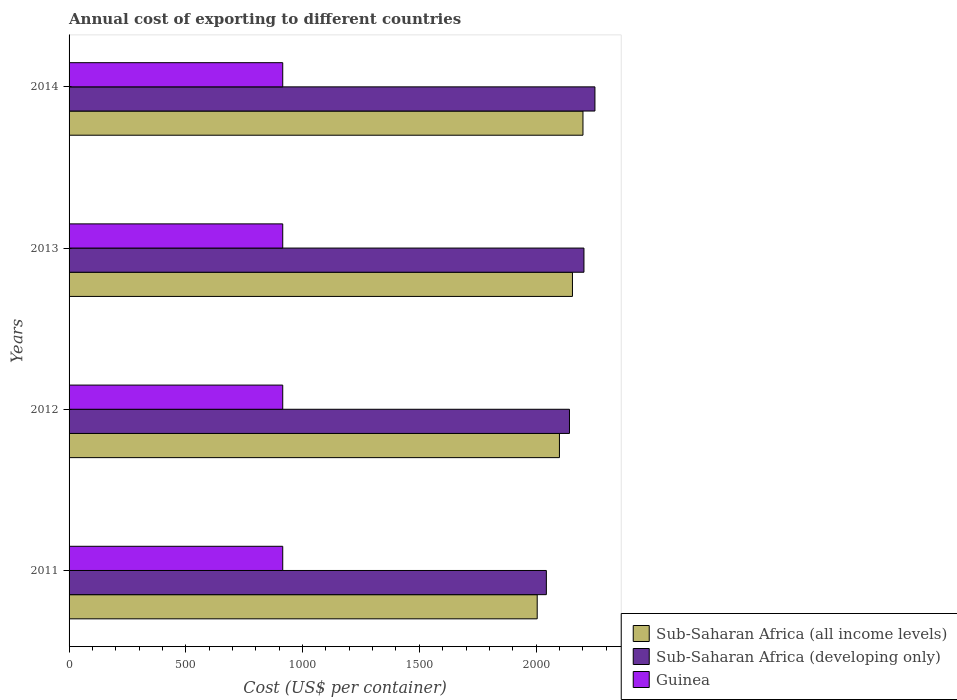In how many cases, is the number of bars for a given year not equal to the number of legend labels?
Ensure brevity in your answer.  0. What is the total annual cost of exporting in Guinea in 2014?
Offer a very short reply. 915. Across all years, what is the maximum total annual cost of exporting in Guinea?
Offer a terse response. 915. Across all years, what is the minimum total annual cost of exporting in Sub-Saharan Africa (developing only)?
Your answer should be compact. 2043.91. In which year was the total annual cost of exporting in Sub-Saharan Africa (developing only) maximum?
Provide a succinct answer. 2014. In which year was the total annual cost of exporting in Sub-Saharan Africa (developing only) minimum?
Your answer should be very brief. 2011. What is the total total annual cost of exporting in Sub-Saharan Africa (developing only) in the graph?
Your answer should be compact. 8643.75. What is the difference between the total annual cost of exporting in Sub-Saharan Africa (developing only) in 2014 and the total annual cost of exporting in Guinea in 2013?
Make the answer very short. 1336.96. What is the average total annual cost of exporting in Sub-Saharan Africa (all income levels) per year?
Give a very brief answer. 2115.28. In the year 2011, what is the difference between the total annual cost of exporting in Guinea and total annual cost of exporting in Sub-Saharan Africa (developing only)?
Ensure brevity in your answer.  -1128.91. What is the ratio of the total annual cost of exporting in Sub-Saharan Africa (all income levels) in 2011 to that in 2012?
Offer a terse response. 0.95. Is the difference between the total annual cost of exporting in Guinea in 2012 and 2014 greater than the difference between the total annual cost of exporting in Sub-Saharan Africa (developing only) in 2012 and 2014?
Give a very brief answer. Yes. What is the difference between the highest and the second highest total annual cost of exporting in Sub-Saharan Africa (developing only)?
Your answer should be compact. 47. What is the difference between the highest and the lowest total annual cost of exporting in Sub-Saharan Africa (all income levels)?
Offer a very short reply. 195.94. In how many years, is the total annual cost of exporting in Sub-Saharan Africa (all income levels) greater than the average total annual cost of exporting in Sub-Saharan Africa (all income levels) taken over all years?
Your response must be concise. 2. What does the 2nd bar from the top in 2011 represents?
Make the answer very short. Sub-Saharan Africa (developing only). What does the 2nd bar from the bottom in 2011 represents?
Your answer should be very brief. Sub-Saharan Africa (developing only). Is it the case that in every year, the sum of the total annual cost of exporting in Sub-Saharan Africa (developing only) and total annual cost of exporting in Sub-Saharan Africa (all income levels) is greater than the total annual cost of exporting in Guinea?
Your answer should be very brief. Yes. How many bars are there?
Give a very brief answer. 12. What is the difference between two consecutive major ticks on the X-axis?
Offer a very short reply. 500. Are the values on the major ticks of X-axis written in scientific E-notation?
Offer a very short reply. No. How many legend labels are there?
Offer a very short reply. 3. How are the legend labels stacked?
Your answer should be compact. Vertical. What is the title of the graph?
Provide a short and direct response. Annual cost of exporting to different countries. Does "Small states" appear as one of the legend labels in the graph?
Your answer should be compact. No. What is the label or title of the X-axis?
Keep it short and to the point. Cost (US$ per container). What is the label or title of the Y-axis?
Offer a terse response. Years. What is the Cost (US$ per container) of Sub-Saharan Africa (all income levels) in 2011?
Give a very brief answer. 2004.76. What is the Cost (US$ per container) of Sub-Saharan Africa (developing only) in 2011?
Your answer should be compact. 2043.91. What is the Cost (US$ per container) of Guinea in 2011?
Provide a succinct answer. 915. What is the Cost (US$ per container) in Sub-Saharan Africa (all income levels) in 2012?
Give a very brief answer. 2099.96. What is the Cost (US$ per container) in Sub-Saharan Africa (developing only) in 2012?
Your answer should be compact. 2142.93. What is the Cost (US$ per container) in Guinea in 2012?
Offer a terse response. 915. What is the Cost (US$ per container) in Sub-Saharan Africa (all income levels) in 2013?
Provide a short and direct response. 2155.7. What is the Cost (US$ per container) of Sub-Saharan Africa (developing only) in 2013?
Your answer should be very brief. 2204.96. What is the Cost (US$ per container) of Guinea in 2013?
Your answer should be very brief. 915. What is the Cost (US$ per container) in Sub-Saharan Africa (all income levels) in 2014?
Provide a succinct answer. 2200.7. What is the Cost (US$ per container) of Sub-Saharan Africa (developing only) in 2014?
Your response must be concise. 2251.96. What is the Cost (US$ per container) of Guinea in 2014?
Your response must be concise. 915. Across all years, what is the maximum Cost (US$ per container) in Sub-Saharan Africa (all income levels)?
Your answer should be very brief. 2200.7. Across all years, what is the maximum Cost (US$ per container) in Sub-Saharan Africa (developing only)?
Make the answer very short. 2251.96. Across all years, what is the maximum Cost (US$ per container) of Guinea?
Your answer should be compact. 915. Across all years, what is the minimum Cost (US$ per container) of Sub-Saharan Africa (all income levels)?
Your answer should be very brief. 2004.76. Across all years, what is the minimum Cost (US$ per container) of Sub-Saharan Africa (developing only)?
Your answer should be compact. 2043.91. Across all years, what is the minimum Cost (US$ per container) of Guinea?
Offer a terse response. 915. What is the total Cost (US$ per container) in Sub-Saharan Africa (all income levels) in the graph?
Your answer should be compact. 8461.12. What is the total Cost (US$ per container) of Sub-Saharan Africa (developing only) in the graph?
Offer a terse response. 8643.75. What is the total Cost (US$ per container) of Guinea in the graph?
Ensure brevity in your answer.  3660. What is the difference between the Cost (US$ per container) in Sub-Saharan Africa (all income levels) in 2011 and that in 2012?
Your response must be concise. -95.2. What is the difference between the Cost (US$ per container) in Sub-Saharan Africa (developing only) in 2011 and that in 2012?
Your response must be concise. -99.02. What is the difference between the Cost (US$ per container) in Guinea in 2011 and that in 2012?
Make the answer very short. 0. What is the difference between the Cost (US$ per container) of Sub-Saharan Africa (all income levels) in 2011 and that in 2013?
Provide a succinct answer. -150.94. What is the difference between the Cost (US$ per container) of Sub-Saharan Africa (developing only) in 2011 and that in 2013?
Keep it short and to the point. -161.05. What is the difference between the Cost (US$ per container) of Sub-Saharan Africa (all income levels) in 2011 and that in 2014?
Offer a very short reply. -195.94. What is the difference between the Cost (US$ per container) of Sub-Saharan Africa (developing only) in 2011 and that in 2014?
Keep it short and to the point. -208.05. What is the difference between the Cost (US$ per container) in Sub-Saharan Africa (all income levels) in 2012 and that in 2013?
Your answer should be compact. -55.74. What is the difference between the Cost (US$ per container) of Sub-Saharan Africa (developing only) in 2012 and that in 2013?
Give a very brief answer. -62.02. What is the difference between the Cost (US$ per container) of Guinea in 2012 and that in 2013?
Provide a short and direct response. 0. What is the difference between the Cost (US$ per container) of Sub-Saharan Africa (all income levels) in 2012 and that in 2014?
Your answer should be compact. -100.74. What is the difference between the Cost (US$ per container) of Sub-Saharan Africa (developing only) in 2012 and that in 2014?
Keep it short and to the point. -109.02. What is the difference between the Cost (US$ per container) of Guinea in 2012 and that in 2014?
Your answer should be very brief. 0. What is the difference between the Cost (US$ per container) in Sub-Saharan Africa (all income levels) in 2013 and that in 2014?
Provide a short and direct response. -45. What is the difference between the Cost (US$ per container) in Sub-Saharan Africa (developing only) in 2013 and that in 2014?
Your answer should be very brief. -47. What is the difference between the Cost (US$ per container) in Sub-Saharan Africa (all income levels) in 2011 and the Cost (US$ per container) in Sub-Saharan Africa (developing only) in 2012?
Offer a terse response. -138.17. What is the difference between the Cost (US$ per container) in Sub-Saharan Africa (all income levels) in 2011 and the Cost (US$ per container) in Guinea in 2012?
Offer a terse response. 1089.76. What is the difference between the Cost (US$ per container) of Sub-Saharan Africa (developing only) in 2011 and the Cost (US$ per container) of Guinea in 2012?
Your response must be concise. 1128.91. What is the difference between the Cost (US$ per container) in Sub-Saharan Africa (all income levels) in 2011 and the Cost (US$ per container) in Sub-Saharan Africa (developing only) in 2013?
Ensure brevity in your answer.  -200.19. What is the difference between the Cost (US$ per container) of Sub-Saharan Africa (all income levels) in 2011 and the Cost (US$ per container) of Guinea in 2013?
Your answer should be compact. 1089.76. What is the difference between the Cost (US$ per container) in Sub-Saharan Africa (developing only) in 2011 and the Cost (US$ per container) in Guinea in 2013?
Ensure brevity in your answer.  1128.91. What is the difference between the Cost (US$ per container) of Sub-Saharan Africa (all income levels) in 2011 and the Cost (US$ per container) of Sub-Saharan Africa (developing only) in 2014?
Offer a very short reply. -247.19. What is the difference between the Cost (US$ per container) in Sub-Saharan Africa (all income levels) in 2011 and the Cost (US$ per container) in Guinea in 2014?
Provide a succinct answer. 1089.76. What is the difference between the Cost (US$ per container) of Sub-Saharan Africa (developing only) in 2011 and the Cost (US$ per container) of Guinea in 2014?
Offer a very short reply. 1128.91. What is the difference between the Cost (US$ per container) in Sub-Saharan Africa (all income levels) in 2012 and the Cost (US$ per container) in Sub-Saharan Africa (developing only) in 2013?
Make the answer very short. -105. What is the difference between the Cost (US$ per container) in Sub-Saharan Africa (all income levels) in 2012 and the Cost (US$ per container) in Guinea in 2013?
Keep it short and to the point. 1184.96. What is the difference between the Cost (US$ per container) in Sub-Saharan Africa (developing only) in 2012 and the Cost (US$ per container) in Guinea in 2013?
Provide a short and direct response. 1227.93. What is the difference between the Cost (US$ per container) of Sub-Saharan Africa (all income levels) in 2012 and the Cost (US$ per container) of Sub-Saharan Africa (developing only) in 2014?
Make the answer very short. -152. What is the difference between the Cost (US$ per container) in Sub-Saharan Africa (all income levels) in 2012 and the Cost (US$ per container) in Guinea in 2014?
Make the answer very short. 1184.96. What is the difference between the Cost (US$ per container) of Sub-Saharan Africa (developing only) in 2012 and the Cost (US$ per container) of Guinea in 2014?
Provide a short and direct response. 1227.93. What is the difference between the Cost (US$ per container) in Sub-Saharan Africa (all income levels) in 2013 and the Cost (US$ per container) in Sub-Saharan Africa (developing only) in 2014?
Give a very brief answer. -96.25. What is the difference between the Cost (US$ per container) of Sub-Saharan Africa (all income levels) in 2013 and the Cost (US$ per container) of Guinea in 2014?
Your answer should be very brief. 1240.7. What is the difference between the Cost (US$ per container) in Sub-Saharan Africa (developing only) in 2013 and the Cost (US$ per container) in Guinea in 2014?
Your answer should be compact. 1289.96. What is the average Cost (US$ per container) of Sub-Saharan Africa (all income levels) per year?
Ensure brevity in your answer.  2115.28. What is the average Cost (US$ per container) of Sub-Saharan Africa (developing only) per year?
Your answer should be compact. 2160.94. What is the average Cost (US$ per container) in Guinea per year?
Provide a succinct answer. 915. In the year 2011, what is the difference between the Cost (US$ per container) in Sub-Saharan Africa (all income levels) and Cost (US$ per container) in Sub-Saharan Africa (developing only)?
Give a very brief answer. -39.15. In the year 2011, what is the difference between the Cost (US$ per container) of Sub-Saharan Africa (all income levels) and Cost (US$ per container) of Guinea?
Keep it short and to the point. 1089.76. In the year 2011, what is the difference between the Cost (US$ per container) of Sub-Saharan Africa (developing only) and Cost (US$ per container) of Guinea?
Your answer should be compact. 1128.91. In the year 2012, what is the difference between the Cost (US$ per container) of Sub-Saharan Africa (all income levels) and Cost (US$ per container) of Sub-Saharan Africa (developing only)?
Offer a very short reply. -42.98. In the year 2012, what is the difference between the Cost (US$ per container) in Sub-Saharan Africa (all income levels) and Cost (US$ per container) in Guinea?
Ensure brevity in your answer.  1184.96. In the year 2012, what is the difference between the Cost (US$ per container) of Sub-Saharan Africa (developing only) and Cost (US$ per container) of Guinea?
Your answer should be very brief. 1227.93. In the year 2013, what is the difference between the Cost (US$ per container) of Sub-Saharan Africa (all income levels) and Cost (US$ per container) of Sub-Saharan Africa (developing only)?
Give a very brief answer. -49.25. In the year 2013, what is the difference between the Cost (US$ per container) of Sub-Saharan Africa (all income levels) and Cost (US$ per container) of Guinea?
Your answer should be compact. 1240.7. In the year 2013, what is the difference between the Cost (US$ per container) of Sub-Saharan Africa (developing only) and Cost (US$ per container) of Guinea?
Offer a very short reply. 1289.96. In the year 2014, what is the difference between the Cost (US$ per container) of Sub-Saharan Africa (all income levels) and Cost (US$ per container) of Sub-Saharan Africa (developing only)?
Ensure brevity in your answer.  -51.25. In the year 2014, what is the difference between the Cost (US$ per container) of Sub-Saharan Africa (all income levels) and Cost (US$ per container) of Guinea?
Offer a very short reply. 1285.7. In the year 2014, what is the difference between the Cost (US$ per container) of Sub-Saharan Africa (developing only) and Cost (US$ per container) of Guinea?
Your answer should be compact. 1336.96. What is the ratio of the Cost (US$ per container) in Sub-Saharan Africa (all income levels) in 2011 to that in 2012?
Offer a very short reply. 0.95. What is the ratio of the Cost (US$ per container) of Sub-Saharan Africa (developing only) in 2011 to that in 2012?
Keep it short and to the point. 0.95. What is the ratio of the Cost (US$ per container) in Guinea in 2011 to that in 2012?
Give a very brief answer. 1. What is the ratio of the Cost (US$ per container) of Sub-Saharan Africa (all income levels) in 2011 to that in 2013?
Offer a very short reply. 0.93. What is the ratio of the Cost (US$ per container) of Sub-Saharan Africa (developing only) in 2011 to that in 2013?
Your response must be concise. 0.93. What is the ratio of the Cost (US$ per container) of Sub-Saharan Africa (all income levels) in 2011 to that in 2014?
Provide a succinct answer. 0.91. What is the ratio of the Cost (US$ per container) in Sub-Saharan Africa (developing only) in 2011 to that in 2014?
Provide a succinct answer. 0.91. What is the ratio of the Cost (US$ per container) of Guinea in 2011 to that in 2014?
Keep it short and to the point. 1. What is the ratio of the Cost (US$ per container) of Sub-Saharan Africa (all income levels) in 2012 to that in 2013?
Your answer should be compact. 0.97. What is the ratio of the Cost (US$ per container) of Sub-Saharan Africa (developing only) in 2012 to that in 2013?
Your response must be concise. 0.97. What is the ratio of the Cost (US$ per container) in Guinea in 2012 to that in 2013?
Give a very brief answer. 1. What is the ratio of the Cost (US$ per container) of Sub-Saharan Africa (all income levels) in 2012 to that in 2014?
Provide a short and direct response. 0.95. What is the ratio of the Cost (US$ per container) of Sub-Saharan Africa (developing only) in 2012 to that in 2014?
Your answer should be very brief. 0.95. What is the ratio of the Cost (US$ per container) of Sub-Saharan Africa (all income levels) in 2013 to that in 2014?
Keep it short and to the point. 0.98. What is the ratio of the Cost (US$ per container) of Sub-Saharan Africa (developing only) in 2013 to that in 2014?
Provide a succinct answer. 0.98. What is the ratio of the Cost (US$ per container) of Guinea in 2013 to that in 2014?
Provide a succinct answer. 1. What is the difference between the highest and the second highest Cost (US$ per container) in Sub-Saharan Africa (developing only)?
Your answer should be very brief. 47. What is the difference between the highest and the lowest Cost (US$ per container) in Sub-Saharan Africa (all income levels)?
Your answer should be compact. 195.94. What is the difference between the highest and the lowest Cost (US$ per container) in Sub-Saharan Africa (developing only)?
Your answer should be very brief. 208.05. 